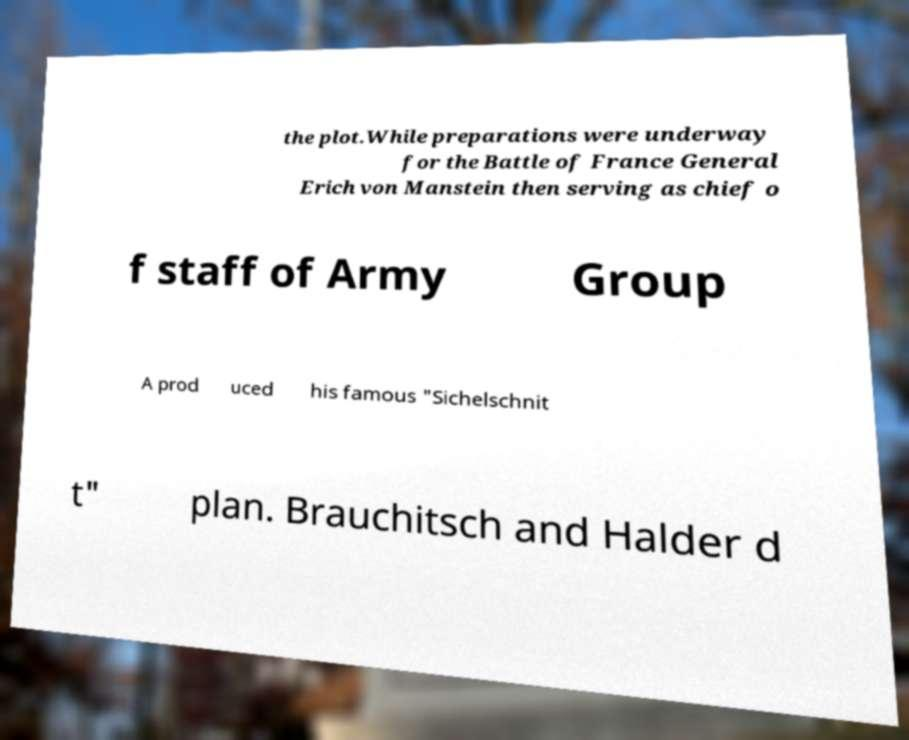Please identify and transcribe the text found in this image. the plot.While preparations were underway for the Battle of France General Erich von Manstein then serving as chief o f staff of Army Group A prod uced his famous "Sichelschnit t" plan. Brauchitsch and Halder d 